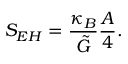<formula> <loc_0><loc_0><loc_500><loc_500>S _ { E H } = \frac { \kappa _ { B } } { \tilde { G } } \frac { A } { 4 } .</formula> 